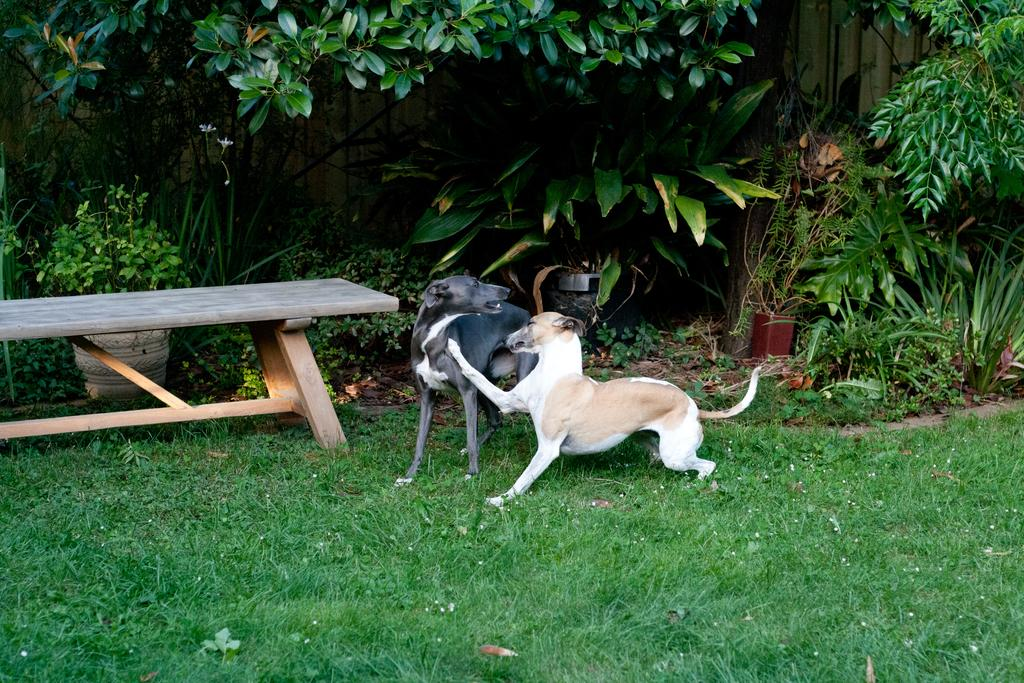How many dogs are present in the image? There are two dogs in the image. What is the surface on which the dogs are standing? The dogs are on a greenery ground. What can be seen in the background of the image? There is a bench and trees in the background of the image. What shape is the mouth of the dog on the left side of the image? There is no dog on the left side of the image, and therefore no mouth to describe its shape. 